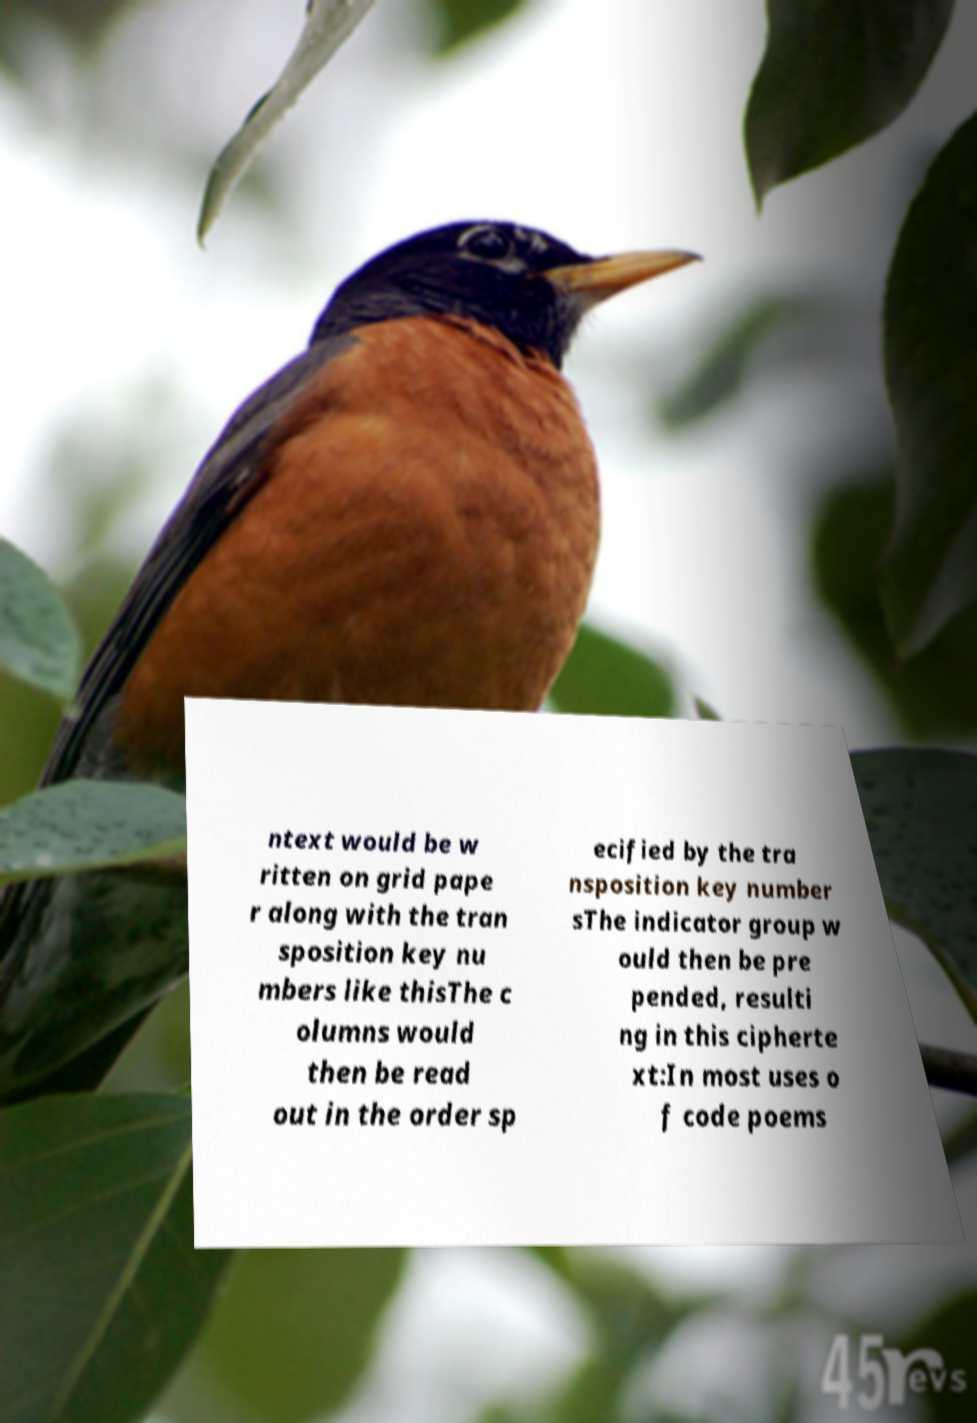Can you read and provide the text displayed in the image?This photo seems to have some interesting text. Can you extract and type it out for me? ntext would be w ritten on grid pape r along with the tran sposition key nu mbers like thisThe c olumns would then be read out in the order sp ecified by the tra nsposition key number sThe indicator group w ould then be pre pended, resulti ng in this cipherte xt:In most uses o f code poems 